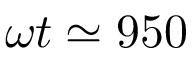<formula> <loc_0><loc_0><loc_500><loc_500>\omega t \simeq 9 5 0</formula> 